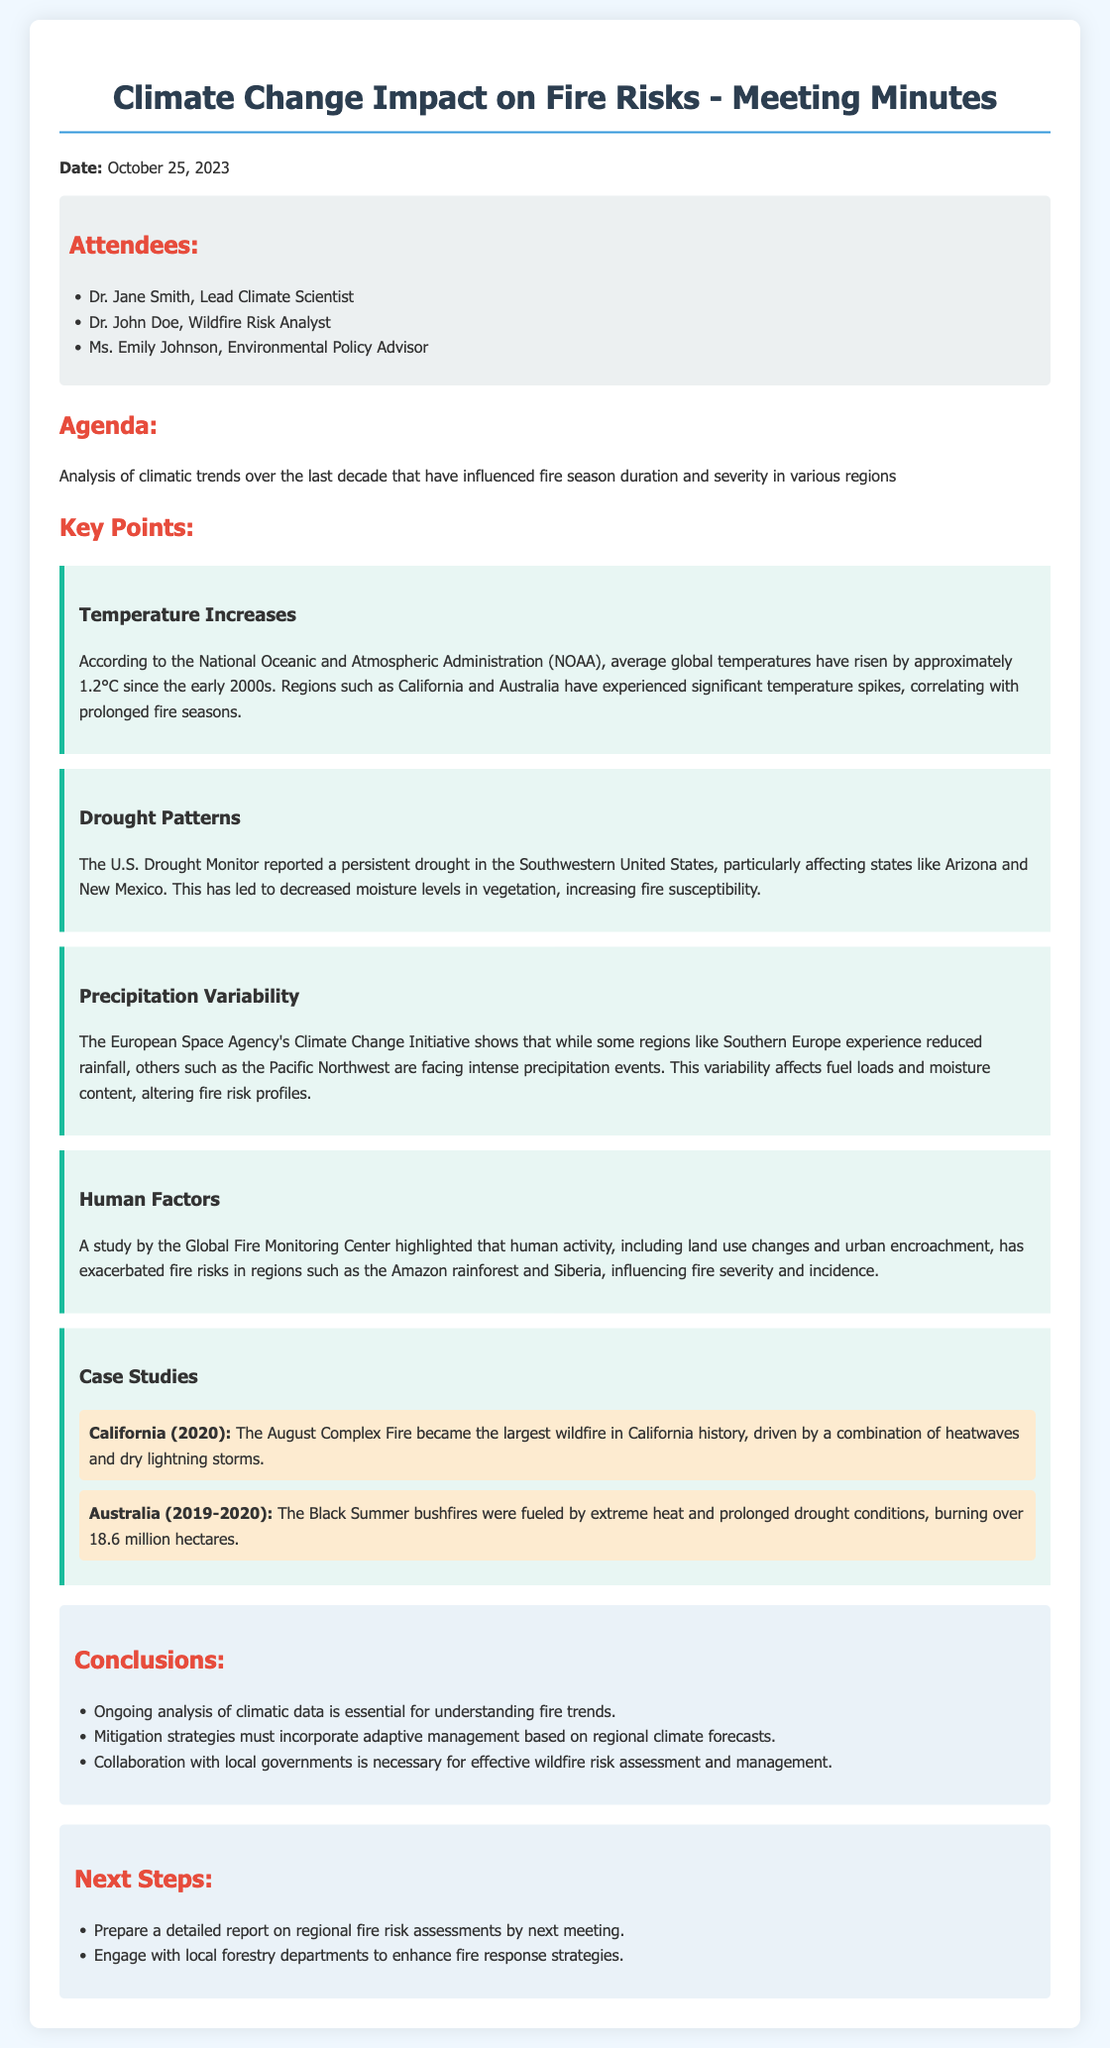What is the date of the meeting? The date of the meeting is mentioned at the top of the document.
Answer: October 25, 2023 Who is the Lead Climate Scientist? The document lists the attendees and their roles, including the Lead Climate Scientist.
Answer: Dr. Jane Smith What climatic trend has risen by approximately 1.2°C? The key points section discusses temperature increases, specifically mentioning global average temperatures.
Answer: Temperature Increases Which region is experiencing a persistent drought? The document cites the U.S. Drought Monitor regarding drought patterns affecting specific areas.
Answer: Southwestern United States What were the Black Summer bushfires fueled by? The case study on Australia details the conditions that led to the bushfires.
Answer: Extreme heat and prolonged drought conditions What must mitigation strategies incorporate according to the conclusions? The conclusions section emphasizes the need for adaptive management in mitigation strategies.
Answer: Adaptive management based on regional climate forecasts What was the August Complex Fire notable for? The case study section highlights a significant fire event in California in 2020.
Answer: Largest wildfire in California history What is a next step mentioned in the document? The next steps section outlines actions to be taken before the next meeting.
Answer: Prepare a detailed report on regional fire risk assessments 